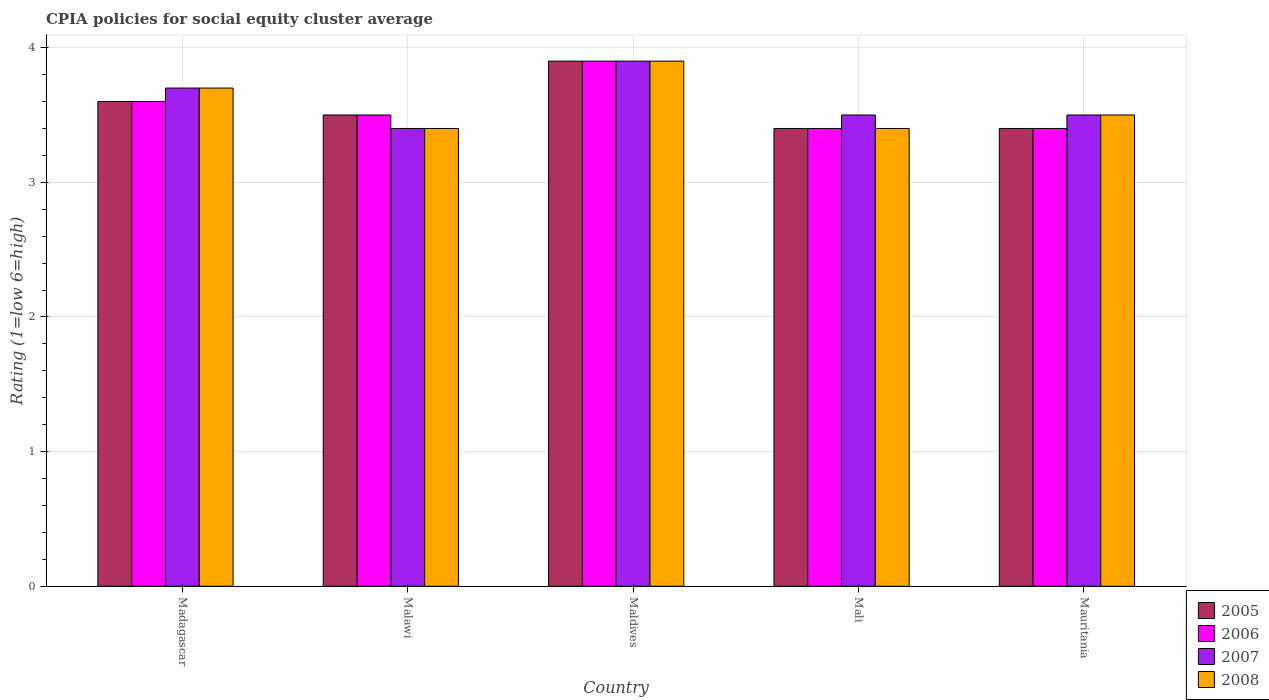Are the number of bars per tick equal to the number of legend labels?
Keep it short and to the point. Yes. What is the label of the 3rd group of bars from the left?
Keep it short and to the point. Maldives. In how many cases, is the number of bars for a given country not equal to the number of legend labels?
Provide a succinct answer. 0. What is the CPIA rating in 2006 in Madagascar?
Provide a succinct answer. 3.6. In which country was the CPIA rating in 2006 maximum?
Your answer should be very brief. Maldives. In which country was the CPIA rating in 2005 minimum?
Your answer should be very brief. Mali. What is the total CPIA rating in 2007 in the graph?
Offer a terse response. 18. What is the difference between the CPIA rating in 2006 in Mali and that in Mauritania?
Keep it short and to the point. 0. What is the difference between the CPIA rating in 2007 in Maldives and the CPIA rating in 2006 in Mauritania?
Your response must be concise. 0.5. What is the average CPIA rating in 2008 per country?
Make the answer very short. 3.58. What is the ratio of the CPIA rating in 2006 in Malawi to that in Mauritania?
Keep it short and to the point. 1.03. What is the difference between the highest and the second highest CPIA rating in 2008?
Your response must be concise. 0.2. Is it the case that in every country, the sum of the CPIA rating in 2008 and CPIA rating in 2007 is greater than the sum of CPIA rating in 2006 and CPIA rating in 2005?
Give a very brief answer. No. What does the 2nd bar from the left in Maldives represents?
Make the answer very short. 2006. What does the 1st bar from the right in Malawi represents?
Your answer should be very brief. 2008. Is it the case that in every country, the sum of the CPIA rating in 2006 and CPIA rating in 2005 is greater than the CPIA rating in 2007?
Your answer should be very brief. Yes. How many countries are there in the graph?
Your answer should be compact. 5. What is the difference between two consecutive major ticks on the Y-axis?
Your answer should be very brief. 1. Are the values on the major ticks of Y-axis written in scientific E-notation?
Your answer should be very brief. No. Does the graph contain grids?
Ensure brevity in your answer.  Yes. How many legend labels are there?
Give a very brief answer. 4. What is the title of the graph?
Your response must be concise. CPIA policies for social equity cluster average. Does "2003" appear as one of the legend labels in the graph?
Keep it short and to the point. No. What is the label or title of the X-axis?
Make the answer very short. Country. What is the label or title of the Y-axis?
Your answer should be very brief. Rating (1=low 6=high). What is the Rating (1=low 6=high) of 2005 in Madagascar?
Make the answer very short. 3.6. What is the Rating (1=low 6=high) of 2007 in Madagascar?
Provide a short and direct response. 3.7. What is the Rating (1=low 6=high) of 2005 in Malawi?
Keep it short and to the point. 3.5. What is the Rating (1=low 6=high) in 2006 in Malawi?
Offer a very short reply. 3.5. What is the Rating (1=low 6=high) of 2008 in Malawi?
Your answer should be compact. 3.4. What is the Rating (1=low 6=high) in 2005 in Mali?
Provide a succinct answer. 3.4. What is the Rating (1=low 6=high) of 2006 in Mali?
Give a very brief answer. 3.4. What is the Rating (1=low 6=high) in 2008 in Mali?
Your answer should be very brief. 3.4. What is the Rating (1=low 6=high) in 2005 in Mauritania?
Your response must be concise. 3.4. What is the Rating (1=low 6=high) of 2008 in Mauritania?
Give a very brief answer. 3.5. Across all countries, what is the maximum Rating (1=low 6=high) in 2006?
Offer a terse response. 3.9. Across all countries, what is the maximum Rating (1=low 6=high) in 2008?
Provide a short and direct response. 3.9. Across all countries, what is the minimum Rating (1=low 6=high) of 2007?
Your response must be concise. 3.4. What is the total Rating (1=low 6=high) of 2005 in the graph?
Your answer should be very brief. 17.8. What is the total Rating (1=low 6=high) of 2006 in the graph?
Your response must be concise. 17.8. What is the total Rating (1=low 6=high) of 2007 in the graph?
Ensure brevity in your answer.  18. What is the difference between the Rating (1=low 6=high) in 2006 in Madagascar and that in Malawi?
Ensure brevity in your answer.  0.1. What is the difference between the Rating (1=low 6=high) of 2007 in Madagascar and that in Malawi?
Your answer should be compact. 0.3. What is the difference between the Rating (1=low 6=high) in 2005 in Madagascar and that in Maldives?
Your response must be concise. -0.3. What is the difference between the Rating (1=low 6=high) of 2006 in Madagascar and that in Maldives?
Your answer should be very brief. -0.3. What is the difference between the Rating (1=low 6=high) in 2007 in Madagascar and that in Maldives?
Offer a terse response. -0.2. What is the difference between the Rating (1=low 6=high) in 2008 in Madagascar and that in Maldives?
Provide a short and direct response. -0.2. What is the difference between the Rating (1=low 6=high) of 2005 in Madagascar and that in Mali?
Make the answer very short. 0.2. What is the difference between the Rating (1=low 6=high) in 2007 in Madagascar and that in Mali?
Your response must be concise. 0.2. What is the difference between the Rating (1=low 6=high) in 2008 in Madagascar and that in Mali?
Provide a succinct answer. 0.3. What is the difference between the Rating (1=low 6=high) of 2005 in Madagascar and that in Mauritania?
Offer a very short reply. 0.2. What is the difference between the Rating (1=low 6=high) in 2006 in Madagascar and that in Mauritania?
Provide a short and direct response. 0.2. What is the difference between the Rating (1=low 6=high) of 2005 in Malawi and that in Maldives?
Make the answer very short. -0.4. What is the difference between the Rating (1=low 6=high) in 2006 in Malawi and that in Maldives?
Provide a succinct answer. -0.4. What is the difference between the Rating (1=low 6=high) of 2005 in Malawi and that in Mali?
Provide a succinct answer. 0.1. What is the difference between the Rating (1=low 6=high) in 2006 in Malawi and that in Mali?
Offer a very short reply. 0.1. What is the difference between the Rating (1=low 6=high) of 2007 in Malawi and that in Mali?
Provide a succinct answer. -0.1. What is the difference between the Rating (1=low 6=high) in 2006 in Malawi and that in Mauritania?
Your response must be concise. 0.1. What is the difference between the Rating (1=low 6=high) of 2005 in Maldives and that in Mali?
Your answer should be compact. 0.5. What is the difference between the Rating (1=low 6=high) of 2007 in Maldives and that in Mali?
Provide a succinct answer. 0.4. What is the difference between the Rating (1=low 6=high) in 2008 in Maldives and that in Mali?
Provide a succinct answer. 0.5. What is the difference between the Rating (1=low 6=high) in 2005 in Maldives and that in Mauritania?
Provide a succinct answer. 0.5. What is the difference between the Rating (1=low 6=high) of 2006 in Maldives and that in Mauritania?
Make the answer very short. 0.5. What is the difference between the Rating (1=low 6=high) of 2006 in Mali and that in Mauritania?
Make the answer very short. 0. What is the difference between the Rating (1=low 6=high) of 2006 in Madagascar and the Rating (1=low 6=high) of 2007 in Malawi?
Give a very brief answer. 0.2. What is the difference between the Rating (1=low 6=high) of 2006 in Madagascar and the Rating (1=low 6=high) of 2008 in Malawi?
Your answer should be compact. 0.2. What is the difference between the Rating (1=low 6=high) in 2007 in Madagascar and the Rating (1=low 6=high) in 2008 in Malawi?
Offer a terse response. 0.3. What is the difference between the Rating (1=low 6=high) of 2005 in Madagascar and the Rating (1=low 6=high) of 2006 in Maldives?
Offer a terse response. -0.3. What is the difference between the Rating (1=low 6=high) of 2007 in Madagascar and the Rating (1=low 6=high) of 2008 in Maldives?
Provide a short and direct response. -0.2. What is the difference between the Rating (1=low 6=high) of 2005 in Madagascar and the Rating (1=low 6=high) of 2006 in Mali?
Your answer should be very brief. 0.2. What is the difference between the Rating (1=low 6=high) of 2005 in Madagascar and the Rating (1=low 6=high) of 2008 in Mali?
Your answer should be very brief. 0.2. What is the difference between the Rating (1=low 6=high) of 2005 in Madagascar and the Rating (1=low 6=high) of 2006 in Mauritania?
Make the answer very short. 0.2. What is the difference between the Rating (1=low 6=high) in 2005 in Madagascar and the Rating (1=low 6=high) in 2007 in Mauritania?
Provide a succinct answer. 0.1. What is the difference between the Rating (1=low 6=high) of 2005 in Madagascar and the Rating (1=low 6=high) of 2008 in Mauritania?
Give a very brief answer. 0.1. What is the difference between the Rating (1=low 6=high) of 2006 in Madagascar and the Rating (1=low 6=high) of 2007 in Mauritania?
Ensure brevity in your answer.  0.1. What is the difference between the Rating (1=low 6=high) of 2005 in Malawi and the Rating (1=low 6=high) of 2007 in Maldives?
Make the answer very short. -0.4. What is the difference between the Rating (1=low 6=high) in 2006 in Malawi and the Rating (1=low 6=high) in 2008 in Maldives?
Give a very brief answer. -0.4. What is the difference between the Rating (1=low 6=high) of 2005 in Malawi and the Rating (1=low 6=high) of 2006 in Mali?
Your answer should be very brief. 0.1. What is the difference between the Rating (1=low 6=high) in 2005 in Malawi and the Rating (1=low 6=high) in 2007 in Mali?
Offer a terse response. 0. What is the difference between the Rating (1=low 6=high) in 2005 in Malawi and the Rating (1=low 6=high) in 2008 in Mali?
Your response must be concise. 0.1. What is the difference between the Rating (1=low 6=high) of 2006 in Malawi and the Rating (1=low 6=high) of 2008 in Mali?
Offer a very short reply. 0.1. What is the difference between the Rating (1=low 6=high) of 2007 in Malawi and the Rating (1=low 6=high) of 2008 in Mali?
Provide a short and direct response. 0. What is the difference between the Rating (1=low 6=high) of 2005 in Malawi and the Rating (1=low 6=high) of 2007 in Mauritania?
Give a very brief answer. 0. What is the difference between the Rating (1=low 6=high) of 2005 in Malawi and the Rating (1=low 6=high) of 2008 in Mauritania?
Make the answer very short. 0. What is the difference between the Rating (1=low 6=high) in 2006 in Malawi and the Rating (1=low 6=high) in 2008 in Mauritania?
Make the answer very short. 0. What is the difference between the Rating (1=low 6=high) of 2005 in Maldives and the Rating (1=low 6=high) of 2006 in Mali?
Your answer should be compact. 0.5. What is the difference between the Rating (1=low 6=high) of 2005 in Maldives and the Rating (1=low 6=high) of 2008 in Mali?
Provide a short and direct response. 0.5. What is the difference between the Rating (1=low 6=high) of 2006 in Maldives and the Rating (1=low 6=high) of 2008 in Mali?
Keep it short and to the point. 0.5. What is the difference between the Rating (1=low 6=high) of 2007 in Maldives and the Rating (1=low 6=high) of 2008 in Mali?
Make the answer very short. 0.5. What is the difference between the Rating (1=low 6=high) of 2005 in Maldives and the Rating (1=low 6=high) of 2007 in Mauritania?
Offer a terse response. 0.4. What is the difference between the Rating (1=low 6=high) in 2006 in Maldives and the Rating (1=low 6=high) in 2008 in Mauritania?
Ensure brevity in your answer.  0.4. What is the difference between the Rating (1=low 6=high) in 2007 in Maldives and the Rating (1=low 6=high) in 2008 in Mauritania?
Give a very brief answer. 0.4. What is the difference between the Rating (1=low 6=high) of 2005 in Mali and the Rating (1=low 6=high) of 2006 in Mauritania?
Keep it short and to the point. 0. What is the difference between the Rating (1=low 6=high) in 2005 in Mali and the Rating (1=low 6=high) in 2007 in Mauritania?
Provide a short and direct response. -0.1. What is the difference between the Rating (1=low 6=high) of 2006 in Mali and the Rating (1=low 6=high) of 2007 in Mauritania?
Offer a very short reply. -0.1. What is the difference between the Rating (1=low 6=high) in 2007 in Mali and the Rating (1=low 6=high) in 2008 in Mauritania?
Keep it short and to the point. 0. What is the average Rating (1=low 6=high) of 2005 per country?
Offer a very short reply. 3.56. What is the average Rating (1=low 6=high) in 2006 per country?
Give a very brief answer. 3.56. What is the average Rating (1=low 6=high) of 2007 per country?
Your response must be concise. 3.6. What is the average Rating (1=low 6=high) in 2008 per country?
Keep it short and to the point. 3.58. What is the difference between the Rating (1=low 6=high) of 2006 and Rating (1=low 6=high) of 2008 in Madagascar?
Provide a succinct answer. -0.1. What is the difference between the Rating (1=low 6=high) of 2005 and Rating (1=low 6=high) of 2008 in Malawi?
Provide a short and direct response. 0.1. What is the difference between the Rating (1=low 6=high) in 2006 and Rating (1=low 6=high) in 2008 in Malawi?
Keep it short and to the point. 0.1. What is the difference between the Rating (1=low 6=high) in 2007 and Rating (1=low 6=high) in 2008 in Malawi?
Your response must be concise. 0. What is the difference between the Rating (1=low 6=high) in 2006 and Rating (1=low 6=high) in 2008 in Maldives?
Ensure brevity in your answer.  0. What is the difference between the Rating (1=low 6=high) of 2005 and Rating (1=low 6=high) of 2007 in Mali?
Your answer should be very brief. -0.1. What is the difference between the Rating (1=low 6=high) in 2005 and Rating (1=low 6=high) in 2008 in Mali?
Offer a very short reply. 0. What is the difference between the Rating (1=low 6=high) of 2006 and Rating (1=low 6=high) of 2007 in Mali?
Your answer should be very brief. -0.1. What is the difference between the Rating (1=low 6=high) in 2006 and Rating (1=low 6=high) in 2008 in Mali?
Make the answer very short. 0. What is the difference between the Rating (1=low 6=high) of 2005 and Rating (1=low 6=high) of 2006 in Mauritania?
Offer a terse response. 0. What is the difference between the Rating (1=low 6=high) of 2007 and Rating (1=low 6=high) of 2008 in Mauritania?
Provide a short and direct response. 0. What is the ratio of the Rating (1=low 6=high) in 2005 in Madagascar to that in Malawi?
Give a very brief answer. 1.03. What is the ratio of the Rating (1=low 6=high) in 2006 in Madagascar to that in Malawi?
Give a very brief answer. 1.03. What is the ratio of the Rating (1=low 6=high) of 2007 in Madagascar to that in Malawi?
Ensure brevity in your answer.  1.09. What is the ratio of the Rating (1=low 6=high) of 2008 in Madagascar to that in Malawi?
Provide a short and direct response. 1.09. What is the ratio of the Rating (1=low 6=high) of 2005 in Madagascar to that in Maldives?
Your answer should be very brief. 0.92. What is the ratio of the Rating (1=low 6=high) of 2007 in Madagascar to that in Maldives?
Keep it short and to the point. 0.95. What is the ratio of the Rating (1=low 6=high) of 2008 in Madagascar to that in Maldives?
Make the answer very short. 0.95. What is the ratio of the Rating (1=low 6=high) in 2005 in Madagascar to that in Mali?
Offer a very short reply. 1.06. What is the ratio of the Rating (1=low 6=high) of 2006 in Madagascar to that in Mali?
Offer a terse response. 1.06. What is the ratio of the Rating (1=low 6=high) in 2007 in Madagascar to that in Mali?
Your answer should be compact. 1.06. What is the ratio of the Rating (1=low 6=high) in 2008 in Madagascar to that in Mali?
Your answer should be compact. 1.09. What is the ratio of the Rating (1=low 6=high) in 2005 in Madagascar to that in Mauritania?
Offer a terse response. 1.06. What is the ratio of the Rating (1=low 6=high) of 2006 in Madagascar to that in Mauritania?
Ensure brevity in your answer.  1.06. What is the ratio of the Rating (1=low 6=high) in 2007 in Madagascar to that in Mauritania?
Offer a terse response. 1.06. What is the ratio of the Rating (1=low 6=high) in 2008 in Madagascar to that in Mauritania?
Provide a short and direct response. 1.06. What is the ratio of the Rating (1=low 6=high) in 2005 in Malawi to that in Maldives?
Keep it short and to the point. 0.9. What is the ratio of the Rating (1=low 6=high) of 2006 in Malawi to that in Maldives?
Offer a very short reply. 0.9. What is the ratio of the Rating (1=low 6=high) of 2007 in Malawi to that in Maldives?
Offer a terse response. 0.87. What is the ratio of the Rating (1=low 6=high) of 2008 in Malawi to that in Maldives?
Offer a terse response. 0.87. What is the ratio of the Rating (1=low 6=high) of 2005 in Malawi to that in Mali?
Keep it short and to the point. 1.03. What is the ratio of the Rating (1=low 6=high) of 2006 in Malawi to that in Mali?
Your answer should be very brief. 1.03. What is the ratio of the Rating (1=low 6=high) in 2007 in Malawi to that in Mali?
Provide a short and direct response. 0.97. What is the ratio of the Rating (1=low 6=high) of 2008 in Malawi to that in Mali?
Provide a short and direct response. 1. What is the ratio of the Rating (1=low 6=high) of 2005 in Malawi to that in Mauritania?
Provide a succinct answer. 1.03. What is the ratio of the Rating (1=low 6=high) in 2006 in Malawi to that in Mauritania?
Ensure brevity in your answer.  1.03. What is the ratio of the Rating (1=low 6=high) of 2007 in Malawi to that in Mauritania?
Provide a short and direct response. 0.97. What is the ratio of the Rating (1=low 6=high) of 2008 in Malawi to that in Mauritania?
Your answer should be compact. 0.97. What is the ratio of the Rating (1=low 6=high) in 2005 in Maldives to that in Mali?
Give a very brief answer. 1.15. What is the ratio of the Rating (1=low 6=high) in 2006 in Maldives to that in Mali?
Your answer should be compact. 1.15. What is the ratio of the Rating (1=low 6=high) of 2007 in Maldives to that in Mali?
Ensure brevity in your answer.  1.11. What is the ratio of the Rating (1=low 6=high) of 2008 in Maldives to that in Mali?
Ensure brevity in your answer.  1.15. What is the ratio of the Rating (1=low 6=high) in 2005 in Maldives to that in Mauritania?
Your answer should be very brief. 1.15. What is the ratio of the Rating (1=low 6=high) of 2006 in Maldives to that in Mauritania?
Provide a succinct answer. 1.15. What is the ratio of the Rating (1=low 6=high) in 2007 in Maldives to that in Mauritania?
Offer a very short reply. 1.11. What is the ratio of the Rating (1=low 6=high) of 2008 in Maldives to that in Mauritania?
Offer a terse response. 1.11. What is the ratio of the Rating (1=low 6=high) in 2005 in Mali to that in Mauritania?
Provide a succinct answer. 1. What is the ratio of the Rating (1=low 6=high) in 2006 in Mali to that in Mauritania?
Make the answer very short. 1. What is the ratio of the Rating (1=low 6=high) of 2007 in Mali to that in Mauritania?
Keep it short and to the point. 1. What is the ratio of the Rating (1=low 6=high) in 2008 in Mali to that in Mauritania?
Make the answer very short. 0.97. What is the difference between the highest and the second highest Rating (1=low 6=high) in 2005?
Ensure brevity in your answer.  0.3. What is the difference between the highest and the second highest Rating (1=low 6=high) in 2006?
Make the answer very short. 0.3. What is the difference between the highest and the second highest Rating (1=low 6=high) of 2007?
Your answer should be compact. 0.2. What is the difference between the highest and the second highest Rating (1=low 6=high) in 2008?
Your answer should be very brief. 0.2. What is the difference between the highest and the lowest Rating (1=low 6=high) in 2006?
Offer a terse response. 0.5. What is the difference between the highest and the lowest Rating (1=low 6=high) of 2007?
Offer a very short reply. 0.5. What is the difference between the highest and the lowest Rating (1=low 6=high) of 2008?
Keep it short and to the point. 0.5. 